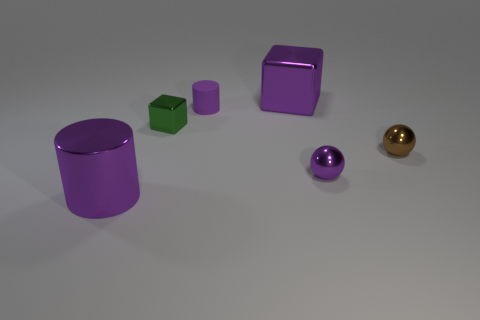Is the number of small brown balls behind the large cylinder greater than the number of small purple rubber objects that are in front of the green block?
Keep it short and to the point. Yes. What is the purple object behind the purple cylinder on the right side of the large purple metallic object left of the tiny green metallic thing made of?
Provide a succinct answer. Metal. There is a large metallic thing in front of the green cube; does it have the same shape as the large object behind the purple sphere?
Offer a very short reply. No. Are there any brown metal cubes that have the same size as the purple sphere?
Provide a short and direct response. No. How many blue objects are either cylinders or big cylinders?
Give a very brief answer. 0. How many other large cylinders are the same color as the large cylinder?
Ensure brevity in your answer.  0. Are there any other things that have the same shape as the tiny purple rubber thing?
Provide a short and direct response. Yes. What number of blocks are matte objects or tiny purple shiny objects?
Provide a short and direct response. 0. The sphere on the left side of the tiny brown shiny thing is what color?
Your answer should be compact. Purple. What is the shape of the metallic thing that is the same size as the metal cylinder?
Your answer should be compact. Cube. 